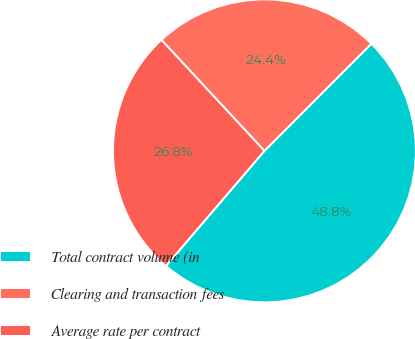Convert chart. <chart><loc_0><loc_0><loc_500><loc_500><pie_chart><fcel>Total contract volume (in<fcel>Clearing and transaction fees<fcel>Average rate per contract<nl><fcel>48.78%<fcel>24.39%<fcel>26.83%<nl></chart> 